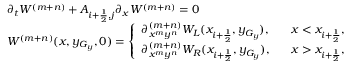Convert formula to latex. <formula><loc_0><loc_0><loc_500><loc_500>\begin{array} { l l } { \partial _ { t } W ^ { ( m + n ) } + A _ { i + \frac { 1 } { 2 } , j } \partial _ { x } W ^ { ( m + n ) } = 0 } \\ { W ^ { ( m + n ) } ( x , y _ { G _ { y } } , 0 ) = \left \{ \begin{array} { l l } { \partial _ { x ^ { m } y ^ { n } } ^ { ( m + n ) } W _ { L } ( x _ { i + \frac { 1 } { 2 } } , y _ { G _ { y } } ) , } & { \, x < x _ { i + \frac { 1 } { 2 } } , } \\ { \partial _ { x ^ { m } y ^ { n } } ^ { ( m + n ) } W _ { R } ( x _ { i + \frac { 1 } { 2 } } , y _ { G _ { y } } ) , } & { \, x > x _ { i + \frac { 1 } { 2 } } , } \end{array} } \end{array}</formula> 